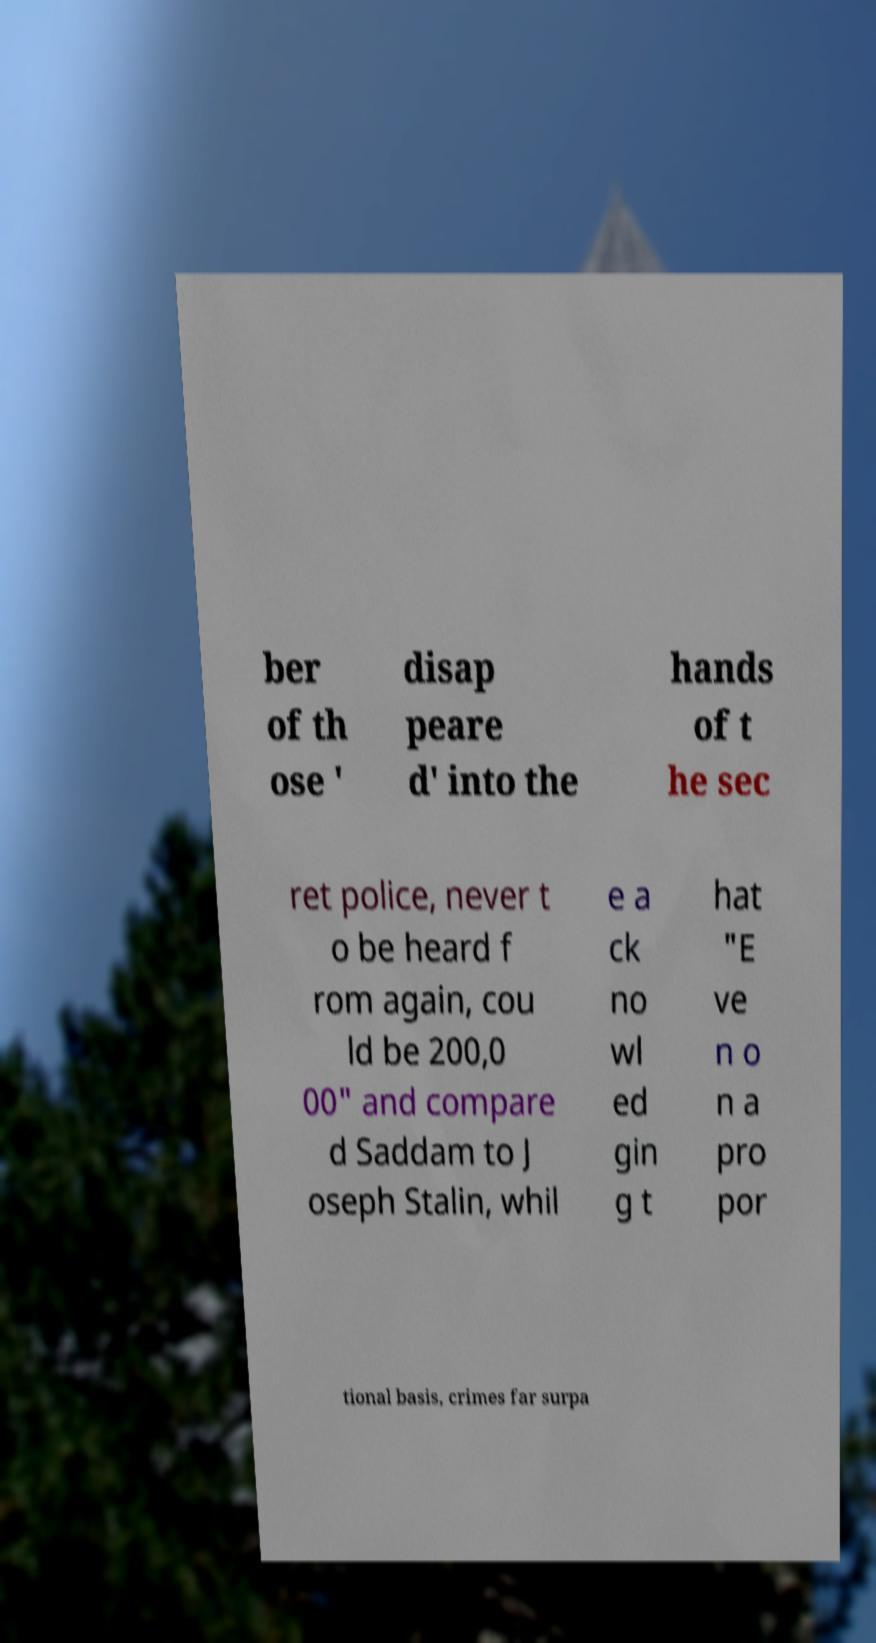Can you read and provide the text displayed in the image?This photo seems to have some interesting text. Can you extract and type it out for me? ber of th ose ' disap peare d' into the hands of t he sec ret police, never t o be heard f rom again, cou ld be 200,0 00" and compare d Saddam to J oseph Stalin, whil e a ck no wl ed gin g t hat "E ve n o n a pro por tional basis, crimes far surpa 